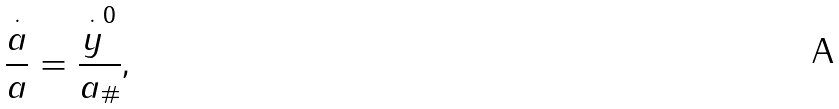Convert formula to latex. <formula><loc_0><loc_0><loc_500><loc_500>\frac { \overset { \cdot } { a } } { a } = \frac { \overset { \cdot } { y } ^ { 0 } } { a _ { \# } } \text {,}</formula> 